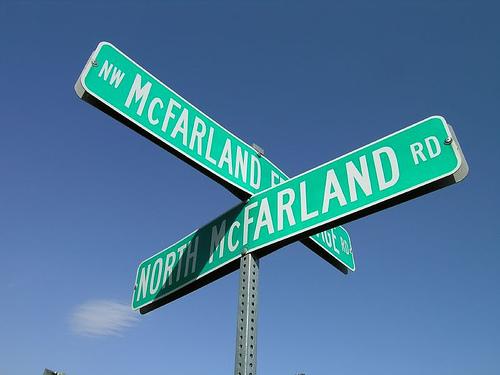Where will a person be by going to the right?
Be succinct. Mcfarland. Is it daytime or nighttime?
Write a very short answer. Daytime. What does this sign say?
Keep it brief. North mcfarland rd. What names are on these street signs ??
Concise answer only. Mcfarland. 